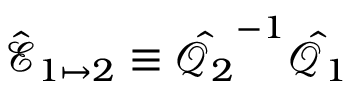Convert formula to latex. <formula><loc_0><loc_0><loc_500><loc_500>\hat { \mathcal { E } } _ { 1 \mapsto 2 } \equiv \hat { \mathcal { Q } _ { 2 } } ^ { - 1 } \hat { \mathcal { Q } _ { 1 } }</formula> 